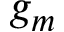Convert formula to latex. <formula><loc_0><loc_0><loc_500><loc_500>g _ { m }</formula> 